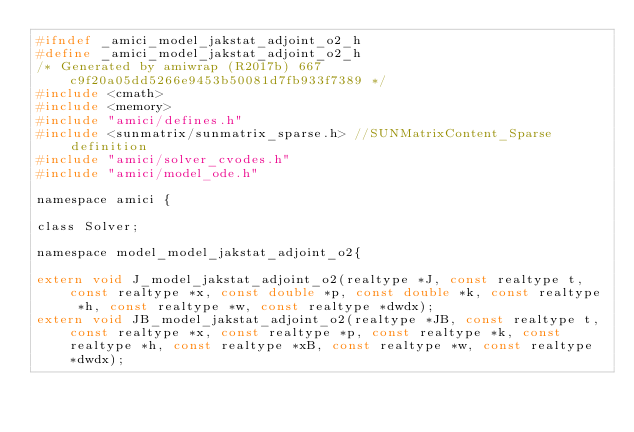<code> <loc_0><loc_0><loc_500><loc_500><_C_>#ifndef _amici_model_jakstat_adjoint_o2_h
#define _amici_model_jakstat_adjoint_o2_h
/* Generated by amiwrap (R2017b) 667c9f20a05dd5266e9453b50081d7fb933f7389 */
#include <cmath>
#include <memory>
#include "amici/defines.h"
#include <sunmatrix/sunmatrix_sparse.h> //SUNMatrixContent_Sparse definition
#include "amici/solver_cvodes.h"
#include "amici/model_ode.h"

namespace amici {

class Solver;

namespace model_model_jakstat_adjoint_o2{

extern void J_model_jakstat_adjoint_o2(realtype *J, const realtype t, const realtype *x, const double *p, const double *k, const realtype *h, const realtype *w, const realtype *dwdx);
extern void JB_model_jakstat_adjoint_o2(realtype *JB, const realtype t, const realtype *x, const realtype *p, const realtype *k, const realtype *h, const realtype *xB, const realtype *w, const realtype *dwdx);</code> 